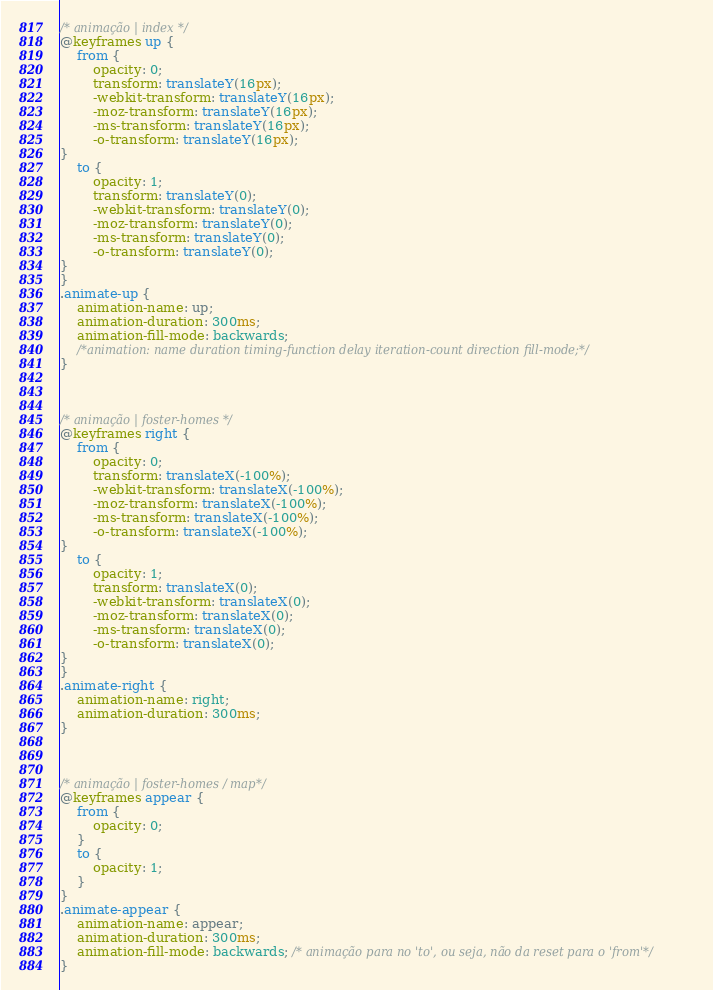<code> <loc_0><loc_0><loc_500><loc_500><_CSS_>/* animação | index */
@keyframes up {
    from {
        opacity: 0;
        transform: translateY(16px);
        -webkit-transform: translateY(16px);
        -moz-transform: translateY(16px);
        -ms-transform: translateY(16px);
        -o-transform: translateY(16px);
}
    to {
        opacity: 1;
        transform: translateY(0);
        -webkit-transform: translateY(0);
        -moz-transform: translateY(0);
        -ms-transform: translateY(0);
        -o-transform: translateY(0);
}
}
.animate-up {
    animation-name: up;
    animation-duration: 300ms;
    animation-fill-mode: backwards;
    /*animation: name duration timing-function delay iteration-count direction fill-mode;*/
}



/* animação | foster-homes */
@keyframes right {
    from {
        opacity: 0;
        transform: translateX(-100%);
        -webkit-transform: translateX(-100%);
        -moz-transform: translateX(-100%);
        -ms-transform: translateX(-100%);
        -o-transform: translateX(-100%);
}
    to {
        opacity: 1;
        transform: translateX(0);
        -webkit-transform: translateX(0);
        -moz-transform: translateX(0);
        -ms-transform: translateX(0);
        -o-transform: translateX(0);
}
}
.animate-right {
    animation-name: right;
    animation-duration: 300ms;
}



/* animação | foster-homes / map*/
@keyframes appear {
    from { 
        opacity: 0;
    }
    to { 
        opacity: 1;
    }
}
.animate-appear {
    animation-name: appear;
    animation-duration: 300ms;
    animation-fill-mode: backwards; /* animação para no 'to', ou seja, não da reset para o 'from'*/
}</code> 